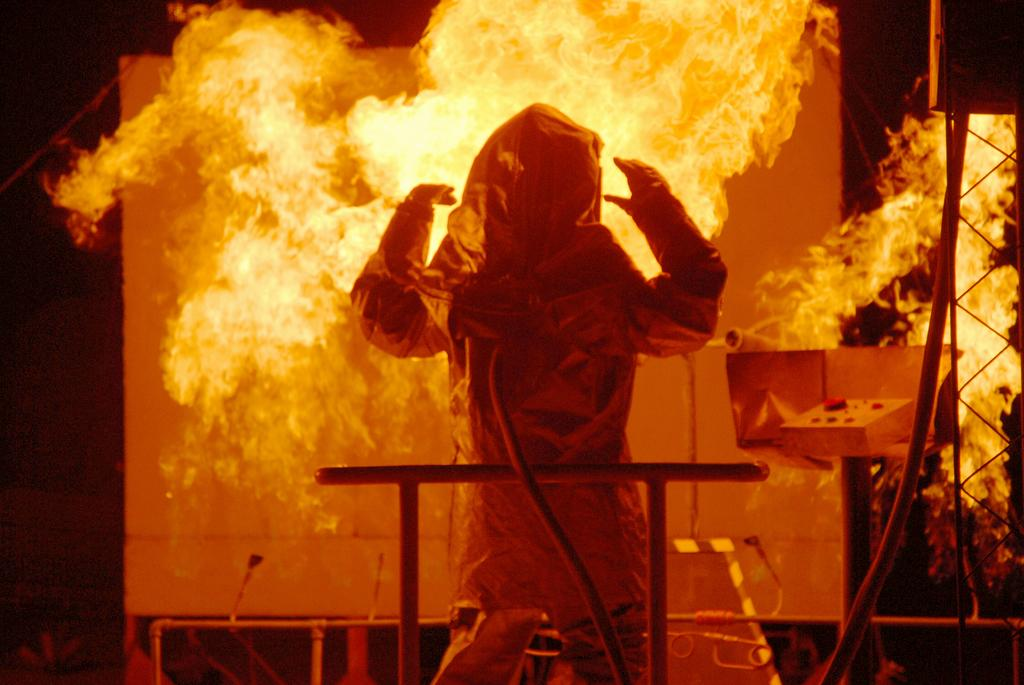What is the main subject of the image? There is a person in the image. What is happening in the image involving the person? There is fire in the image, which may be related to the person's activity. What objects can be seen in the image besides the person and the fire? There is a board and rods in the image. How would you describe the overall appearance of the image? The background of the image is dark. What type of yoke is being used to blow air into the mine in the image? There is no yoke, blowing of air, or mine present in the image. 